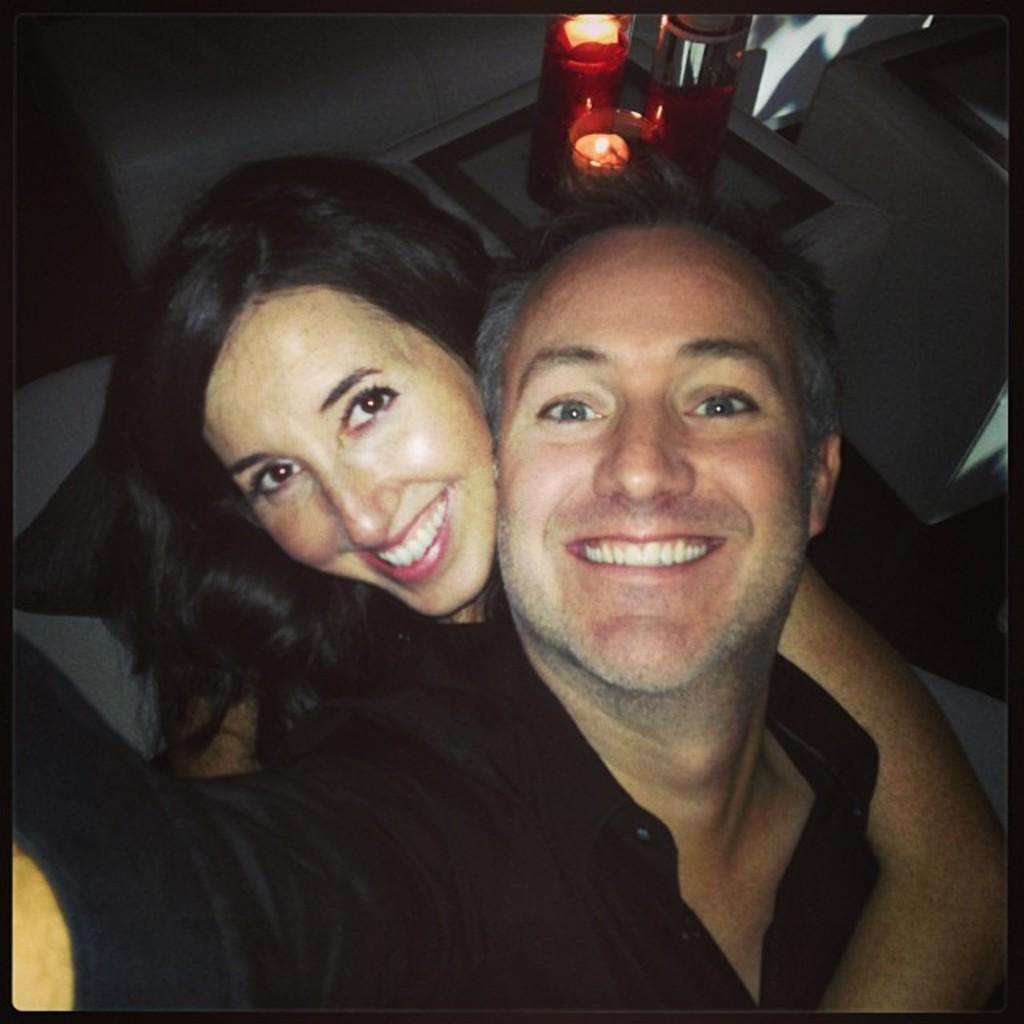Could you give a brief overview of what you see in this image? In this image, we can see a man and a woman smiling, we can see two candles kept on the white surface. 